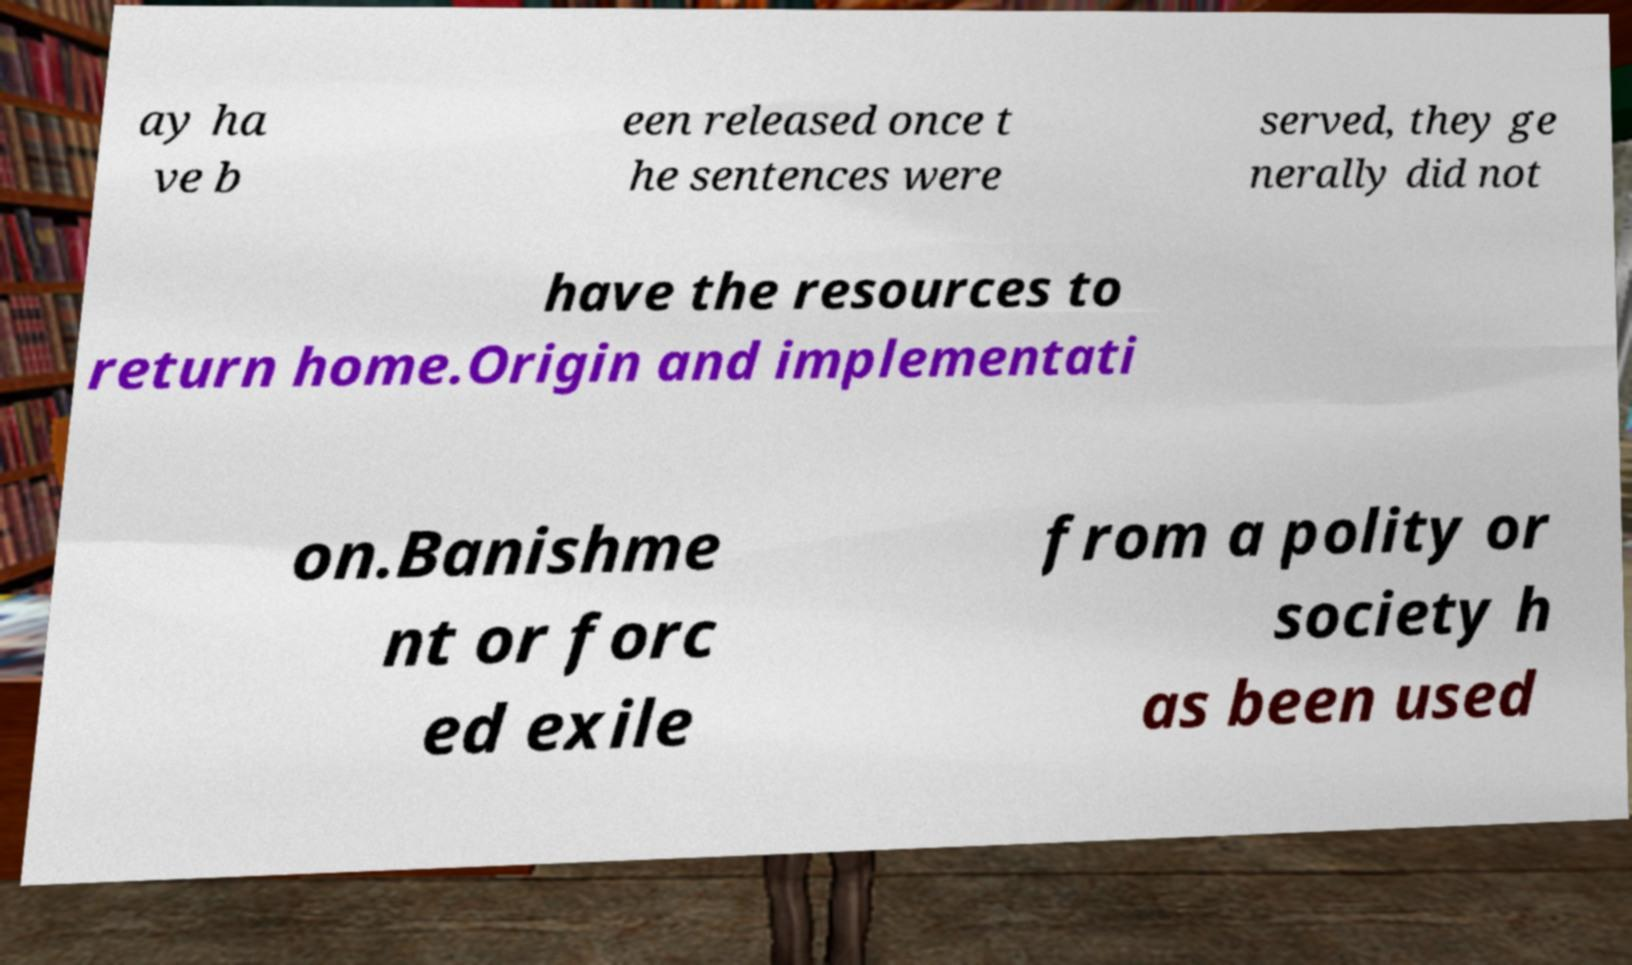What messages or text are displayed in this image? I need them in a readable, typed format. ay ha ve b een released once t he sentences were served, they ge nerally did not have the resources to return home.Origin and implementati on.Banishme nt or forc ed exile from a polity or society h as been used 